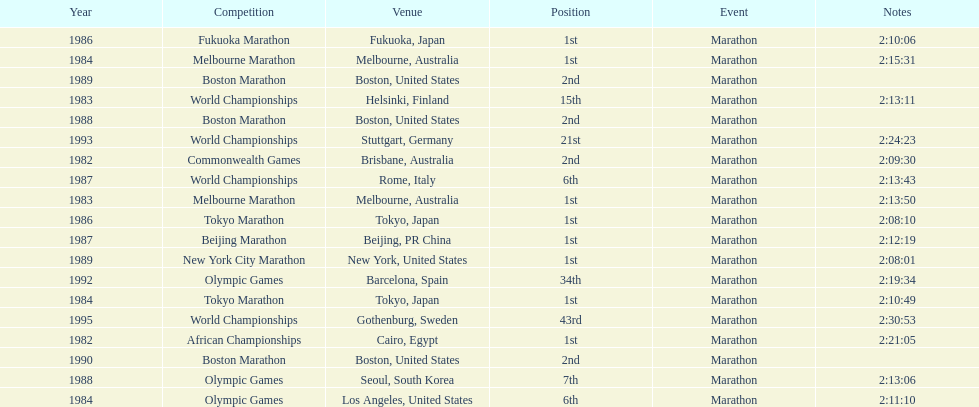Which was the only competition to occur in china? Beijing Marathon. 